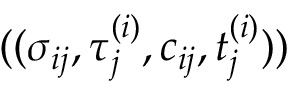<formula> <loc_0><loc_0><loc_500><loc_500>( ( \sigma _ { i j } , \tau _ { j } ^ { ( i ) } , c _ { i j } , t _ { j } ^ { ( i ) } ) )</formula> 